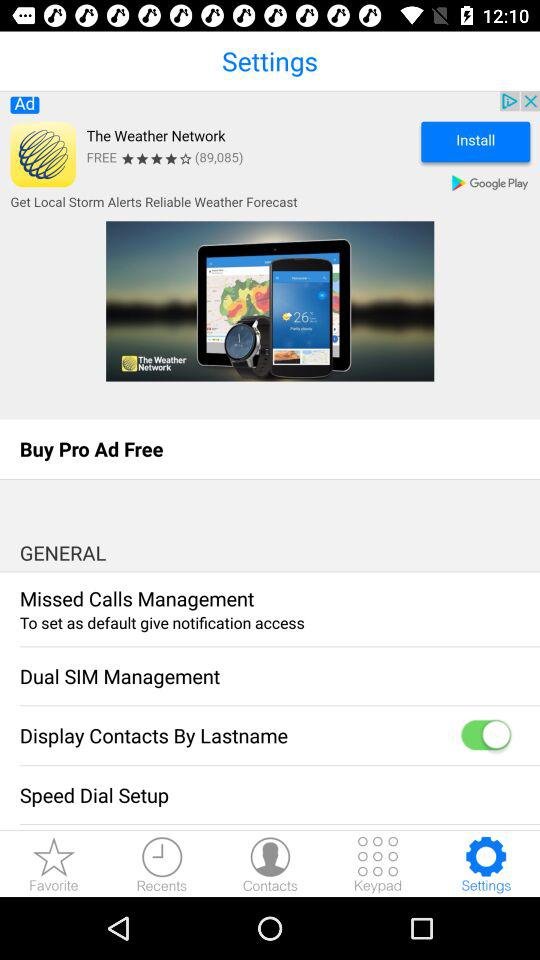What is the application name? The application name is "2GIS Dialer". 